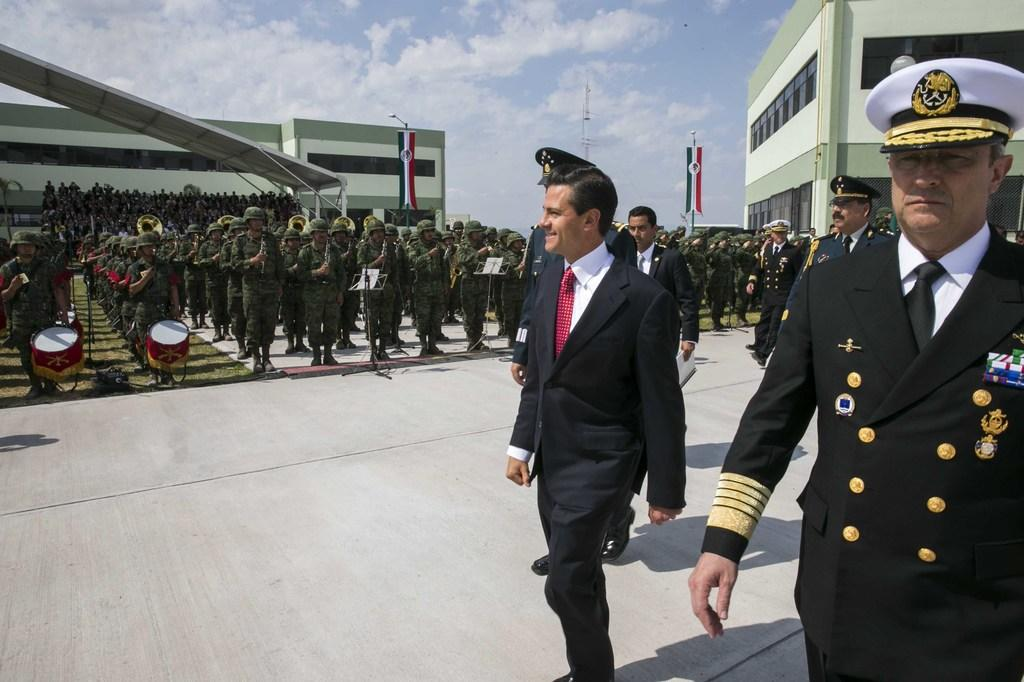Who or what can be seen in the image? There are people in the image. What structures are visible in the image? There are buildings in the image. What decorative or symbolic items are present in the image? There are flags in the image. What supports or holds up the flags in the image? There are poles in the image. What musical instruments are featured in the image? There are musical drums in the image. What is the weather like in the image? The sky is cloudy in the image. What other unspecified objects can be seen in the image? There are unspecified objects in the image. How does the person in the image touch the top of the flagpole? There is no person touching the top of the flagpole in the image. What type of material is the rub used for cleaning the musical drums in the image? There is no rub or cleaning material mentioned in the image; the musical drums are stationary. 